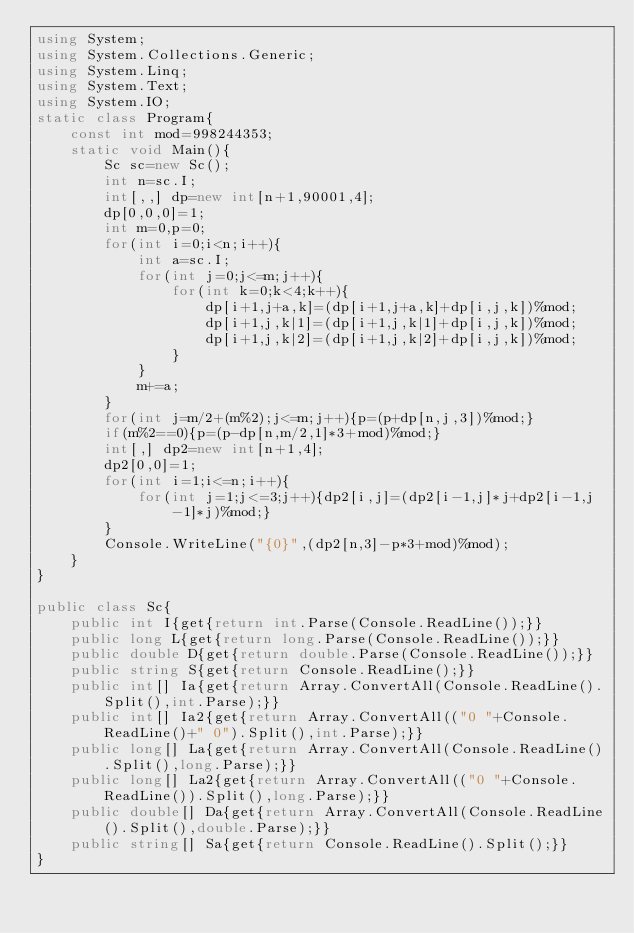Convert code to text. <code><loc_0><loc_0><loc_500><loc_500><_C#_>using System;
using System.Collections.Generic;
using System.Linq;
using System.Text;
using System.IO;
static class Program{
	const int mod=998244353;
	static void Main(){
		Sc sc=new Sc();
		int n=sc.I;
		int[,,] dp=new int[n+1,90001,4];
		dp[0,0,0]=1;
		int m=0,p=0;
		for(int i=0;i<n;i++){
			int a=sc.I;
			for(int j=0;j<=m;j++){
				for(int k=0;k<4;k++){
					dp[i+1,j+a,k]=(dp[i+1,j+a,k]+dp[i,j,k])%mod;
					dp[i+1,j,k|1]=(dp[i+1,j,k|1]+dp[i,j,k])%mod;
					dp[i+1,j,k|2]=(dp[i+1,j,k|2]+dp[i,j,k])%mod;
				}
			}
			m+=a;
		}
		for(int j=m/2+(m%2);j<=m;j++){p=(p+dp[n,j,3])%mod;}
		if(m%2==0){p=(p-dp[n,m/2,1]*3+mod)%mod;}
		int[,] dp2=new int[n+1,4];
		dp2[0,0]=1;
		for(int i=1;i<=n;i++){
			for(int j=1;j<=3;j++){dp2[i,j]=(dp2[i-1,j]*j+dp2[i-1,j-1]*j)%mod;}
		}
		Console.WriteLine("{0}",(dp2[n,3]-p*3+mod)%mod);
	}
}

public class Sc{
	public int I{get{return int.Parse(Console.ReadLine());}}
	public long L{get{return long.Parse(Console.ReadLine());}}
	public double D{get{return double.Parse(Console.ReadLine());}}
	public string S{get{return Console.ReadLine();}}
	public int[] Ia{get{return Array.ConvertAll(Console.ReadLine().Split(),int.Parse);}}
	public int[] Ia2{get{return Array.ConvertAll(("0 "+Console.ReadLine()+" 0").Split(),int.Parse);}}
	public long[] La{get{return Array.ConvertAll(Console.ReadLine().Split(),long.Parse);}}
	public long[] La2{get{return Array.ConvertAll(("0 "+Console.ReadLine()).Split(),long.Parse);}}
	public double[] Da{get{return Array.ConvertAll(Console.ReadLine().Split(),double.Parse);}}
	public string[] Sa{get{return Console.ReadLine().Split();}}
}</code> 